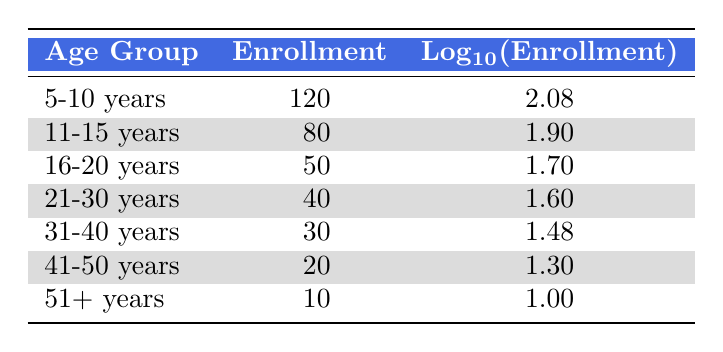What is the enrollment number for the age group 5-10 years? The table lists the enrollment numbers for various age groups. For the age group "5-10 years," the enrollment number is directly given as 120.
Answer: 120 What is the logarithmic value of enrollment for the age group 31-40 years? The table shows the enrollment numbers along with their logarithmic values. For the age group "31-40 years," the logarithmic value is provided as 1.48.
Answer: 1.48 How many total students are enrolled in music lessons across all age groups? To find the total enrollment, we add the numbers from each age group: 120 + 80 + 50 + 40 + 30 + 20 + 10 = 350.
Answer: 350 Is the enrollment number for the age group 21-30 years greater than that for 41-50 years? The enrollment number for "21-30 years" is 40, while for "41-50 years" it is 20. Since 40 is greater than 20, the statement is true.
Answer: Yes What is the average enrollment number for the age groups 11-15 years and 16-20 years? The enrollment numbers for these groups are 80 (11-15 years) and 50 (16-20 years). Adding these gives 80 + 50 = 130. Now, dividing by 2, we get 130 / 2 = 65 as the average.
Answer: 65 Which age group has the lowest enrollment number? By reviewing the table, we see the "51+ years" age group has the lowest enrollment number, which is 10.
Answer: 51+ years What is the difference in enrollment between the age groups 16-20 years and 21-30 years? The enrollment for "16-20 years" is 50 and for "21-30 years" it is 40. The difference is 50 - 40 = 10.
Answer: 10 Are there fewer than 100 students enrolled in the age group 41-50 years? The enrollment number for "41-50 years" is 20. Since this number is less than 100, the statement is true.
Answer: Yes 